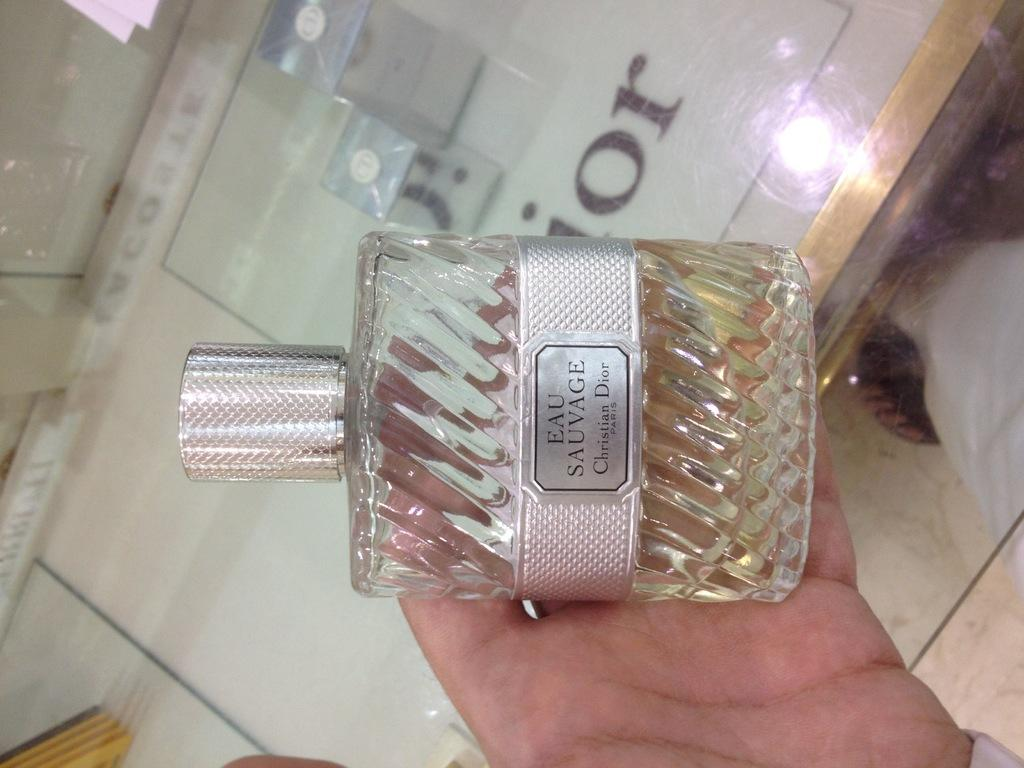<image>
Render a clear and concise summary of the photo. Person holding a perfume that says "EAU SAUVAGE" on it. 